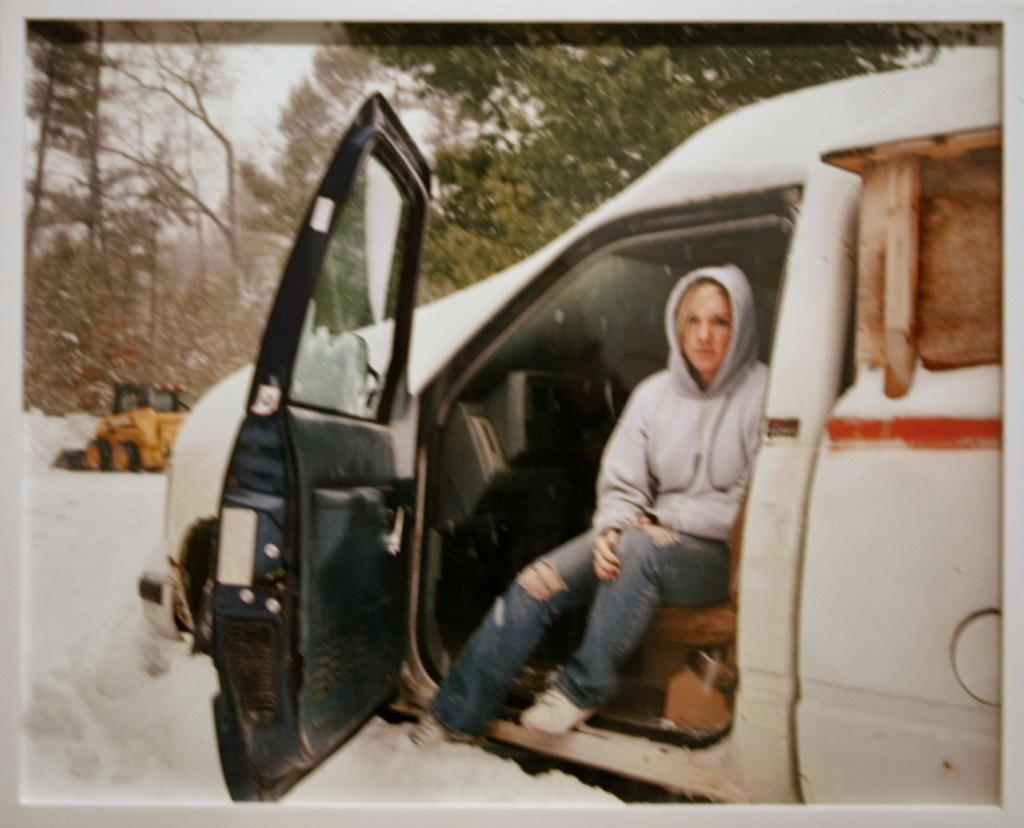What is the woman in the image doing? The woman is seated in a car. What is the condition of the car in the image? The car is in the ice. What can be seen in the background of the image? There is an earth-moving vehicle and trees visible in the background. How many dogs are visible in the image? There are no dogs present in the image. What type of drink is the woman holding in the image? The image does not show the woman holding any drink. 